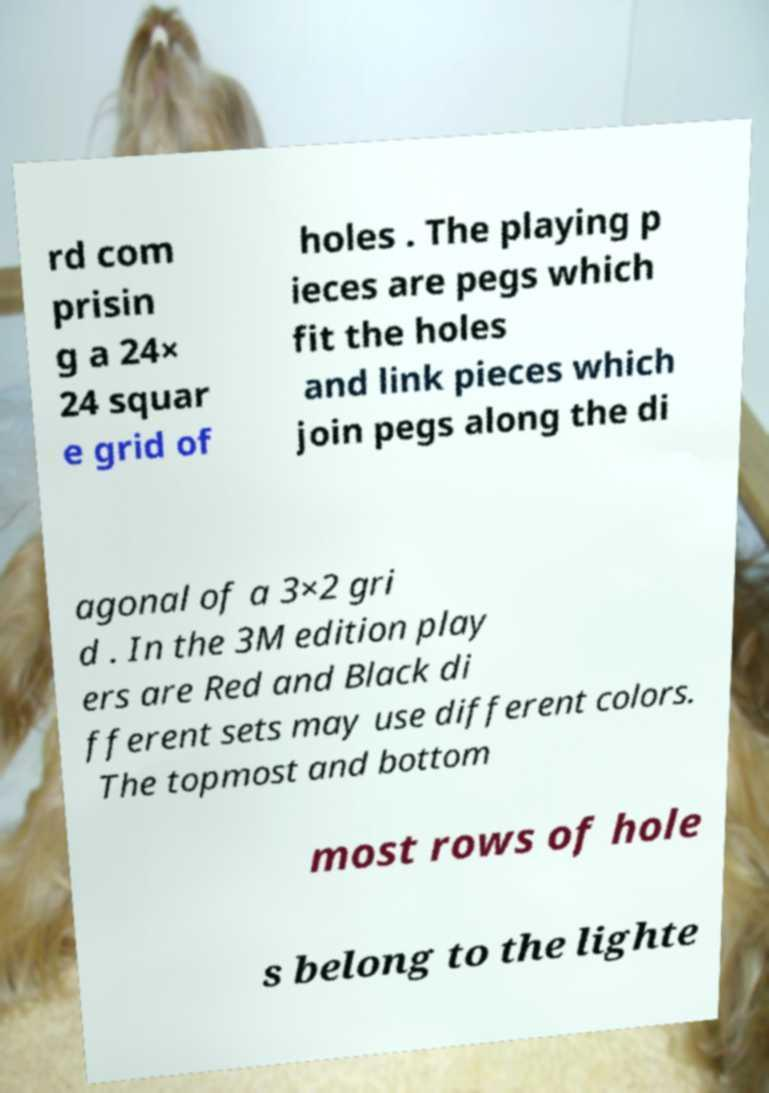Could you extract and type out the text from this image? rd com prisin g a 24× 24 squar e grid of holes . The playing p ieces are pegs which fit the holes and link pieces which join pegs along the di agonal of a 3×2 gri d . In the 3M edition play ers are Red and Black di fferent sets may use different colors. The topmost and bottom most rows of hole s belong to the lighte 